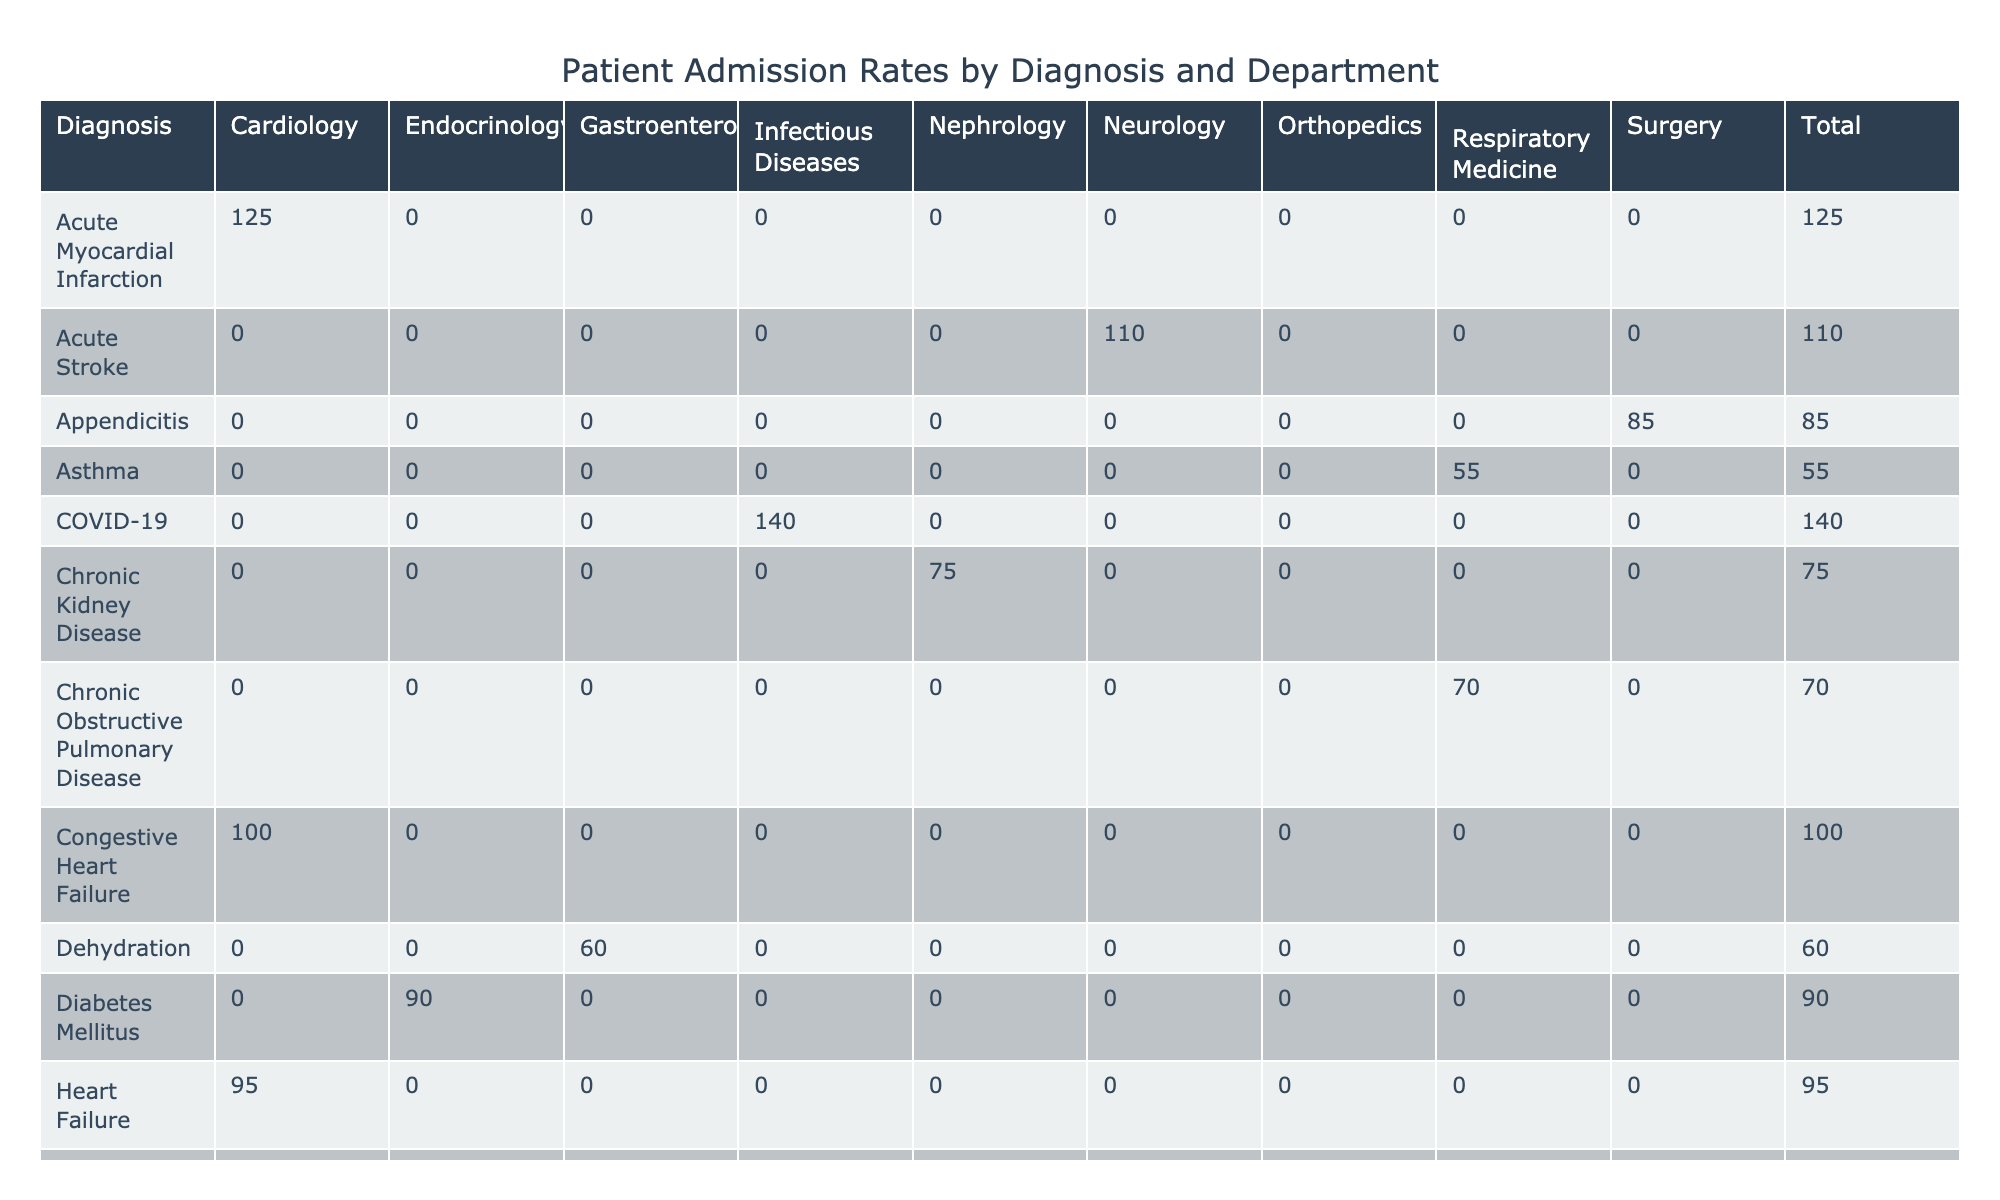What is the admission rate for Acute Myocardial Infarction in the Cardiology department? The table indicates that for Acute Myocardial Infarction, the value corresponding to the Cardiology department is explicitly mentioned. By checking the respective cell in the table, we find it is 125.
Answer: 125 Which department has the highest admission rate? To determine the department with the highest admission rate, we scan through the total admission rates for each department. The max value appears under Orthopedics with a rate of 150 for Hip Fracture.
Answer: Orthopedics Is the admission rate for Diabetes Mellitus higher than that for Congestive Heart Failure? Comparing the admission rates in the table, Diabetes Mellitus shows a rate of 90 and Congestive Heart Failure shows a rate of 100. Since 90 is not higher than 100, the answer is no.
Answer: No What is the total admission rate for the Infectious Diseases department? We look at the rates listed under the Infectious Diseases department—Sepsis with 130 and COVID-19 with 140. By summing these values: 130 + 140 = 270, we determine the total admission rate.
Answer: 270 How does the average admission rate for Respiratory Medicine compare to that of Orthopedics? Respiratory Medicine has three rates: Pneumonia (80), Chronic Obstructive Pulmonary Disease (70), and Asthma (55), which total 205. The average is 205/3 = approximately 68.33. For Orthopedics, the total is 150 + 40 = 190 with an average of 190/2 = 95. Since 68.33 is less than 95, Respiratory Medicine's average is lower.
Answer: Lower What is the difference between the highest and the lowest admission rates in the table? The highest admission rate we found is 150 (Hip Fracture, Orthopedics) and the lowest is 40 (Osteoarthritis, Orthopedics). The difference is calculated as 150 - 40 = 110.
Answer: 110 Are there any cases where the admission rate reaches 140 or more? By scanning the admission rates provided, we find two instances: COVID-19 at 140 and Sepsis at 130 which is less than 140. Thus, there is at least one case where the admission rate reaches 140 or more.
Answer: Yes Which diagnosis in the Orthopedics department has a lower admission rate than Heart Failure in Cardiology? We see that Heart Failure in the Cardiology department has an admission rate of 95. In the Orthopedics department, Osteoarthritis has a rate of 40, while Hip Fracture has a rate of 150. Therefore, only Osteoarthritis has a lower rate than Heart Failure.
Answer: Osteoarthritis How many departments have an admission rate above 100? Reviewing the admission rates above 100 involves checking each department. The qualifying cases are: Cardiology (Acute Myocardial Infarction and Congestive Heart Failure), Neurology (Acute Stroke), Infectious Diseases (Sepsis and COVID-19), and Orthopedics (Hip Fracture), totaling 6 observations across 4 different departments.
Answer: 4 